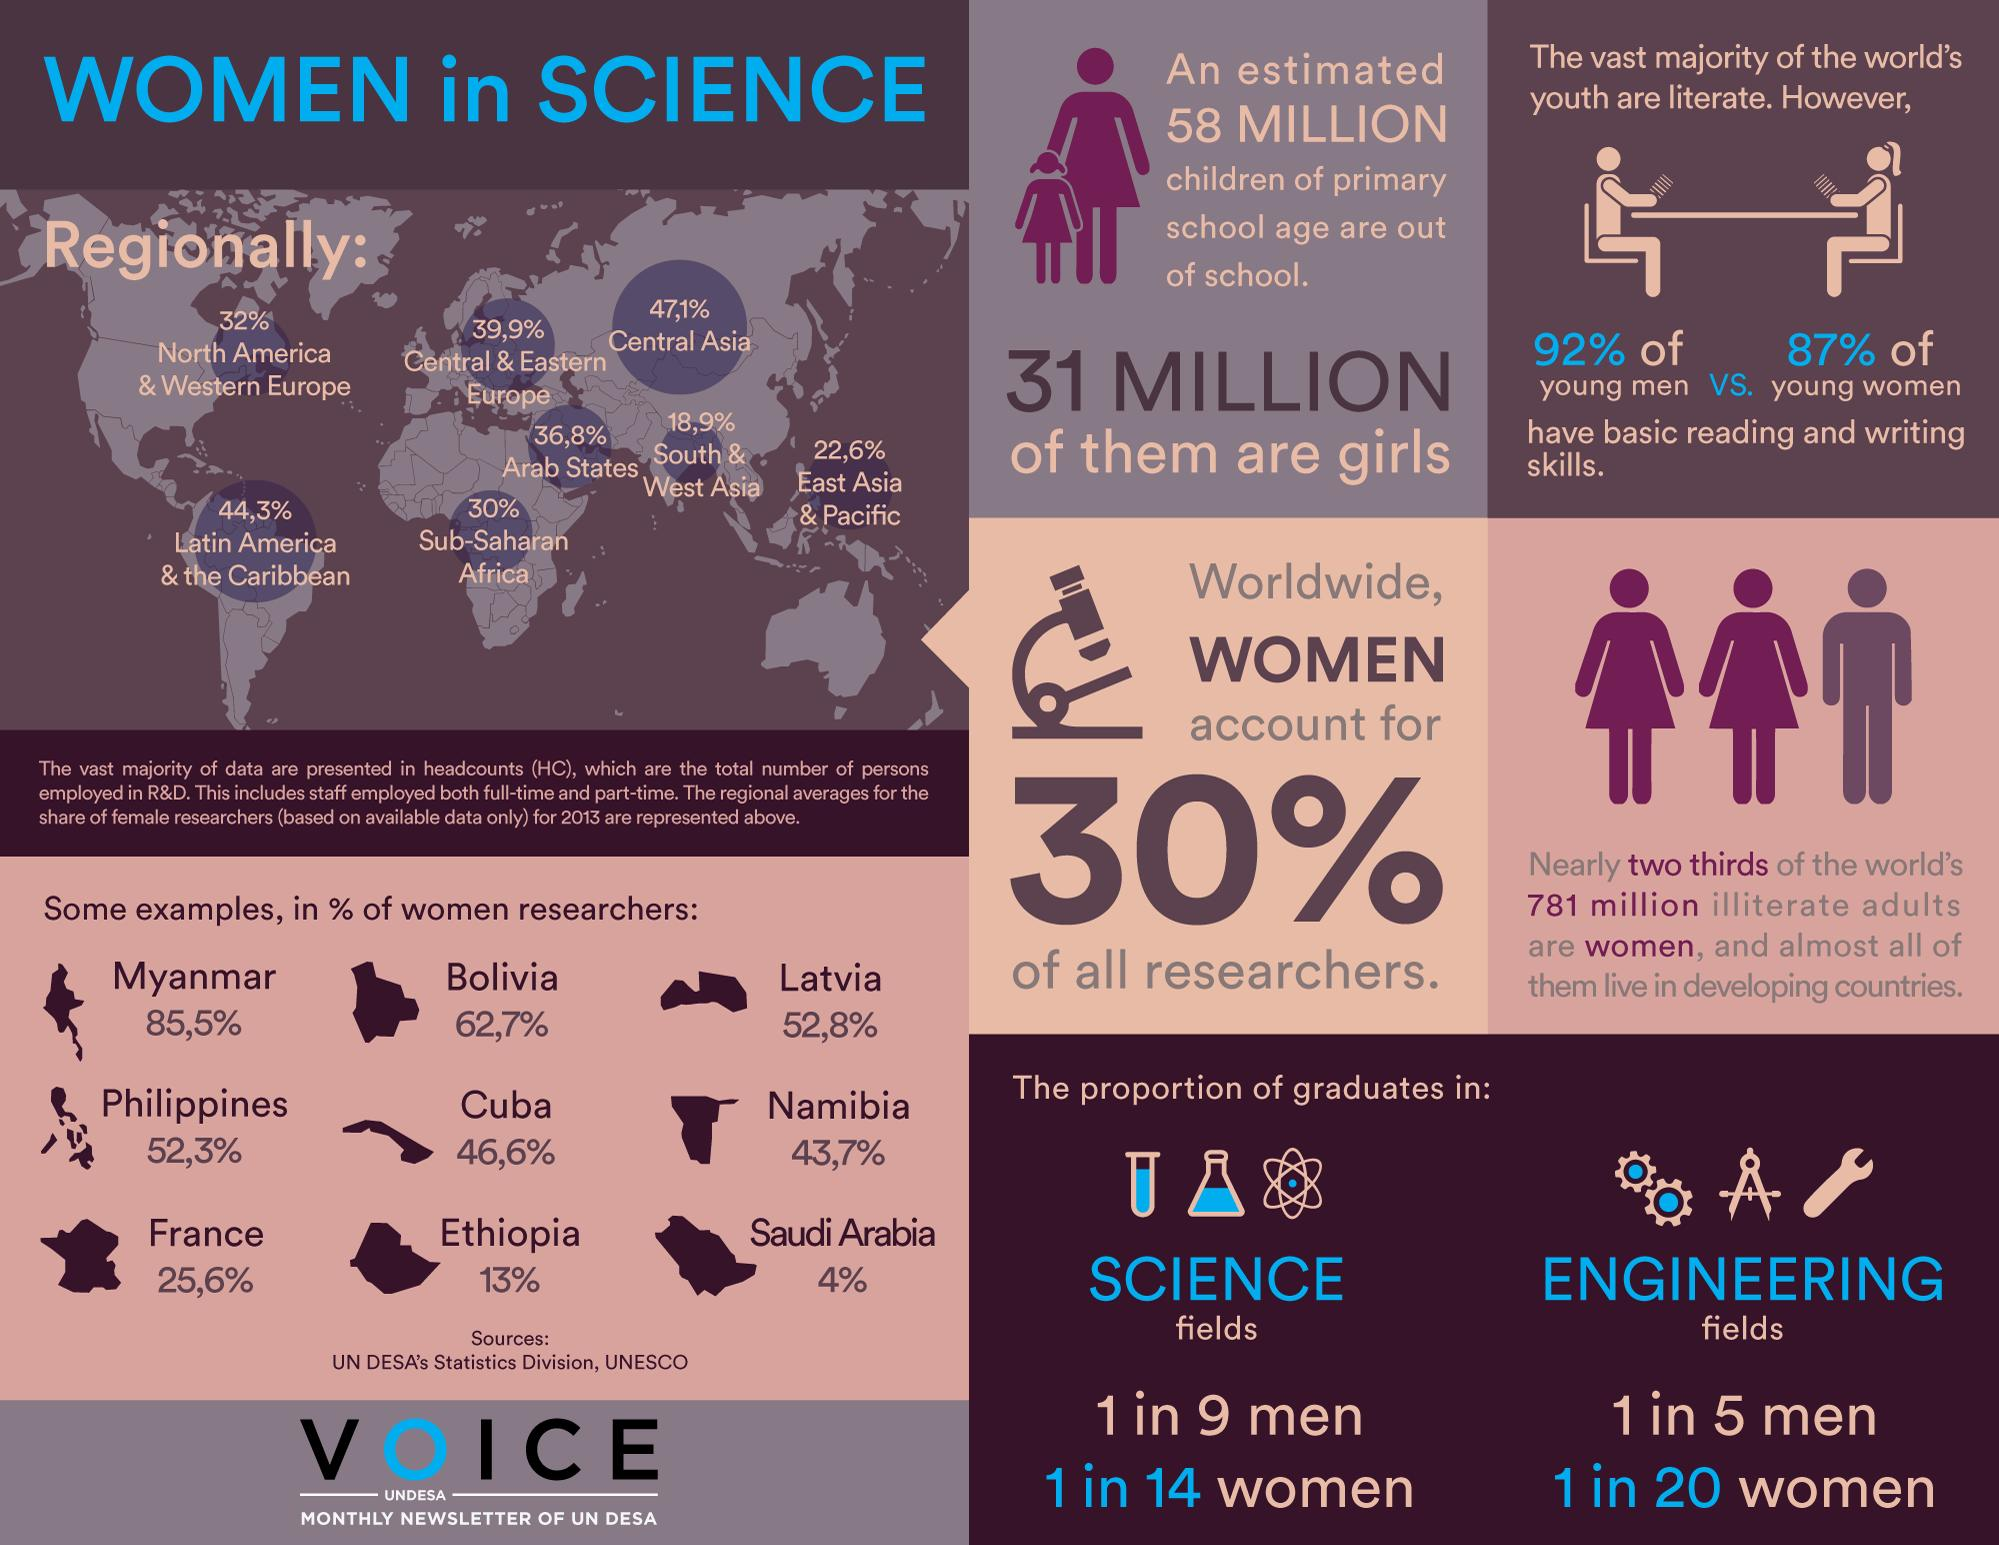List a handful of essential elements in this visual. Cuba has the second lowest percentage of women researchers among the countries considered, which are Bolivia, Cuba, and Ethiopia. The percentage gap in literacy rate between young men and women is 5%. The country with the highest number of women researchers among the Philippines, France, and Namibia is the Philippines. The percentage of women researchers in Latvia is 52.8%. There are approximately 27 million boys who are currently out of primary school. 